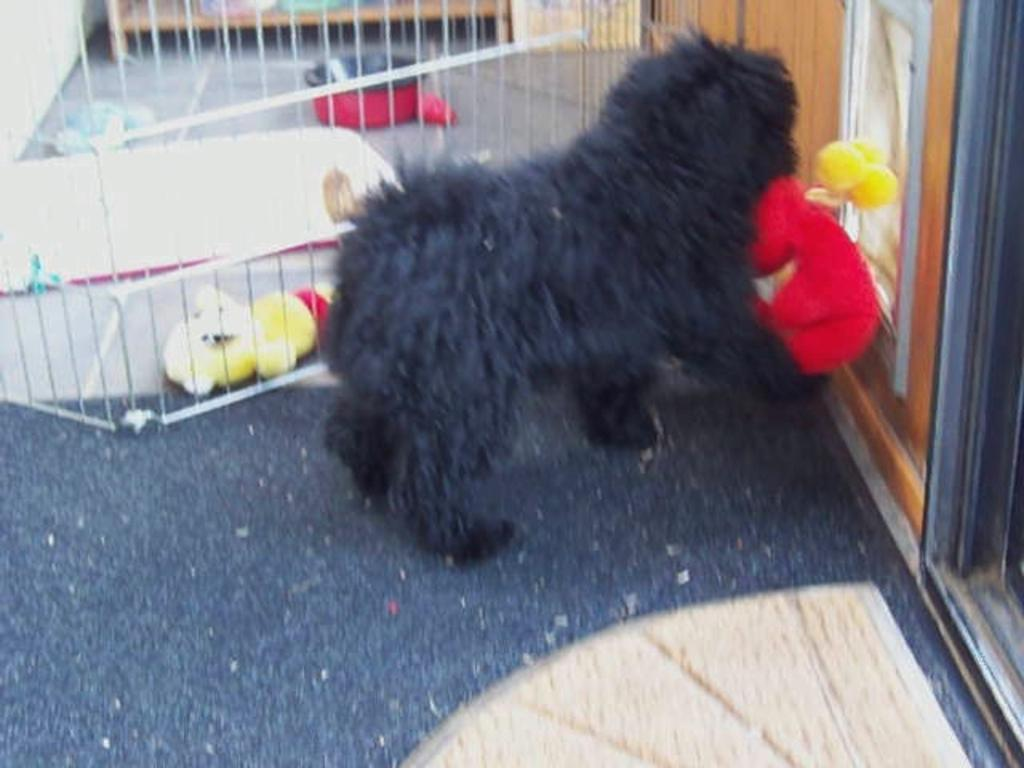What type of animal can be seen in the image? There is a dog in the image. What else is present in the image besides the dog? There are toys, a railing, a bowl, a wall, and a mat in the image. Can you describe the bowl in the image? There is a bowl in the image, but its contents are not specified. What is the purpose of the railing in the image? The purpose of the railing is not clear from the image, but it could be for safety or decoration. What type of feast is being prepared on the slope in the image? There is no feast or slope present in the image; it features a dog, toys, a railing, a bowl, a wall, and a mat. 